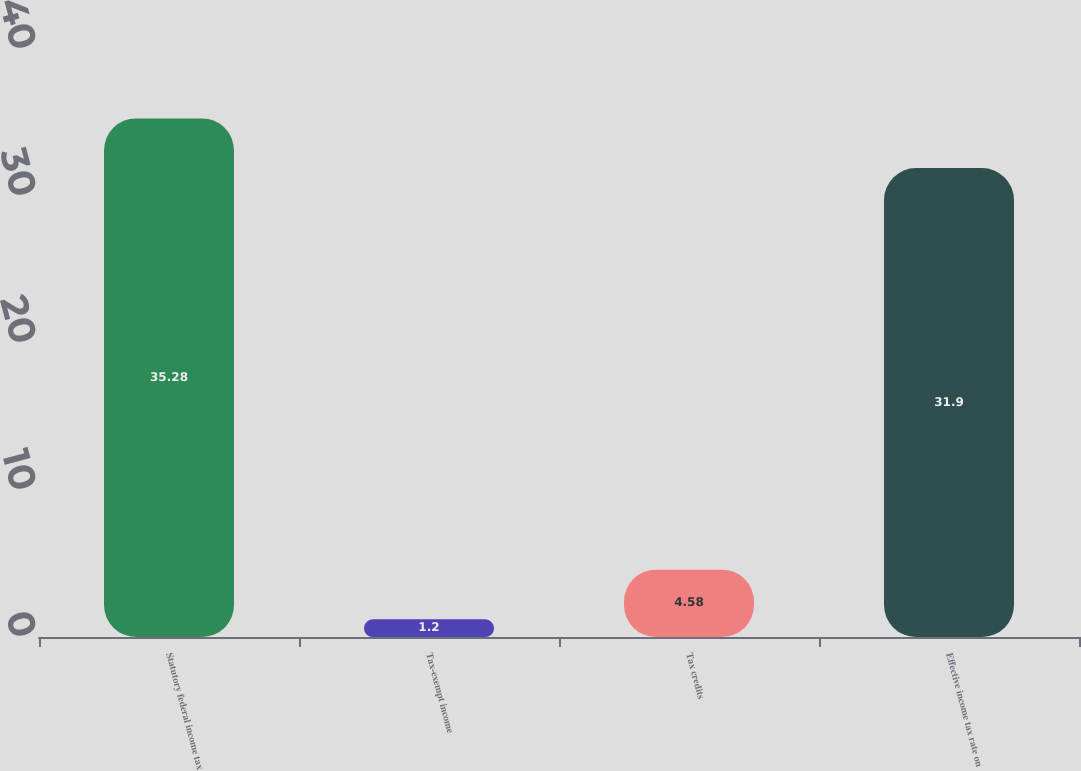Convert chart. <chart><loc_0><loc_0><loc_500><loc_500><bar_chart><fcel>Statutory federal income tax<fcel>Tax-exempt income<fcel>Tax credits<fcel>Effective income tax rate on<nl><fcel>35.28<fcel>1.2<fcel>4.58<fcel>31.9<nl></chart> 